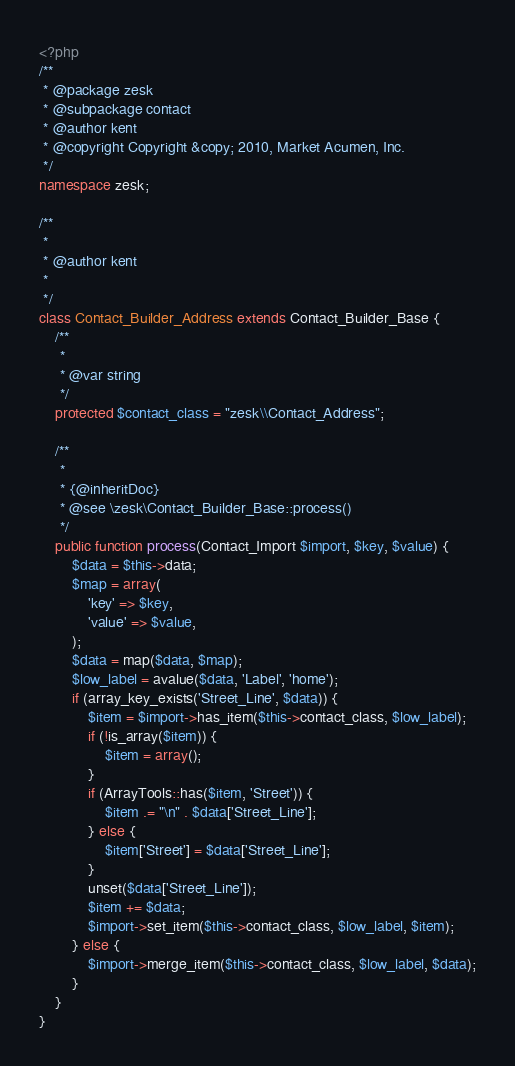Convert code to text. <code><loc_0><loc_0><loc_500><loc_500><_PHP_><?php
/**
 * @package zesk
 * @subpackage contact
 * @author kent
 * @copyright Copyright &copy; 2010, Market Acumen, Inc.
 */
namespace zesk;

/**
 *
 * @author kent
 *
 */
class Contact_Builder_Address extends Contact_Builder_Base {
	/**
	 *
	 * @var string
	 */
	protected $contact_class = "zesk\\Contact_Address";

	/**
	 *
	 * {@inheritDoc}
	 * @see \zesk\Contact_Builder_Base::process()
	 */
	public function process(Contact_Import $import, $key, $value) {
		$data = $this->data;
		$map = array(
			'key' => $key,
			'value' => $value,
		);
		$data = map($data, $map);
		$low_label = avalue($data, 'Label', 'home');
		if (array_key_exists('Street_Line', $data)) {
			$item = $import->has_item($this->contact_class, $low_label);
			if (!is_array($item)) {
				$item = array();
			}
			if (ArrayTools::has($item, 'Street')) {
				$item .= "\n" . $data['Street_Line'];
			} else {
				$item['Street'] = $data['Street_Line'];
			}
			unset($data['Street_Line']);
			$item += $data;
			$import->set_item($this->contact_class, $low_label, $item);
		} else {
			$import->merge_item($this->contact_class, $low_label, $data);
		}
	}
}
</code> 